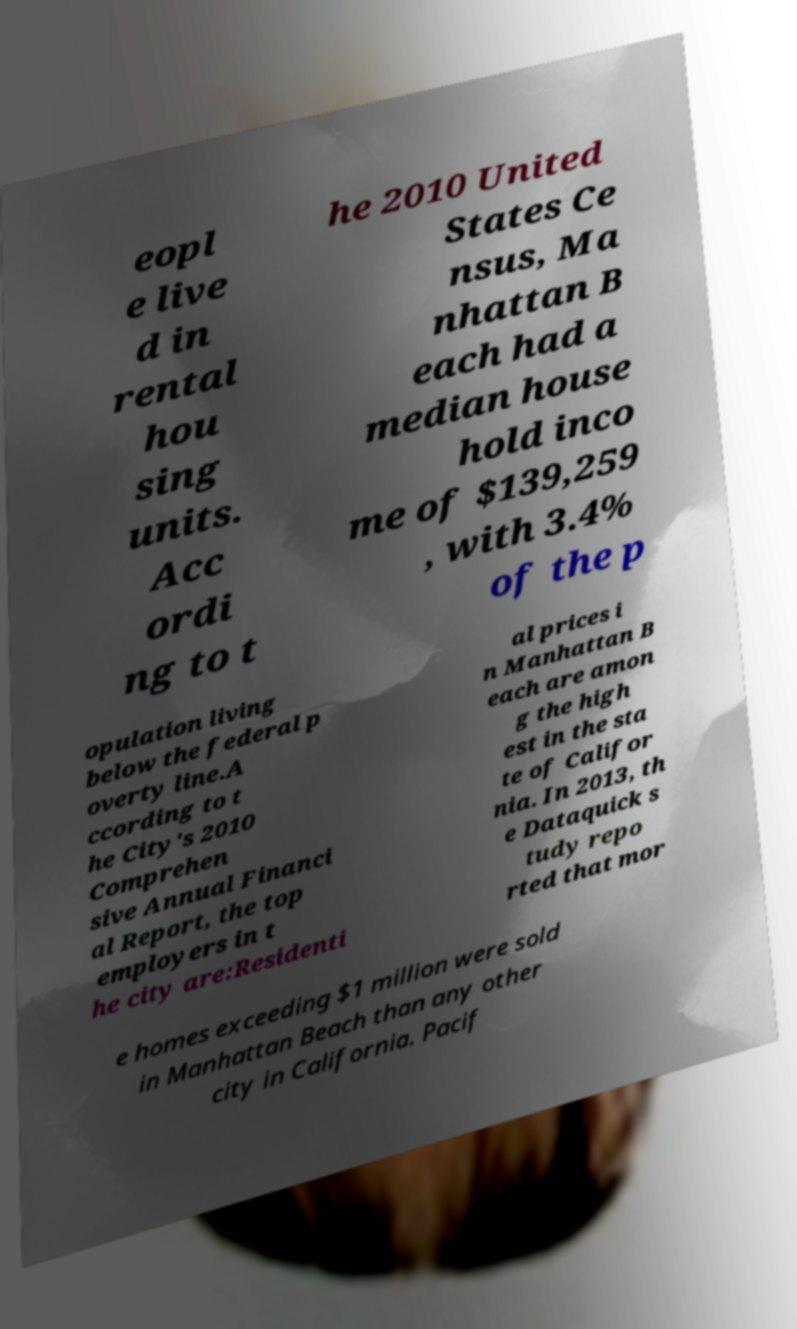Can you accurately transcribe the text from the provided image for me? eopl e live d in rental hou sing units. Acc ordi ng to t he 2010 United States Ce nsus, Ma nhattan B each had a median house hold inco me of $139,259 , with 3.4% of the p opulation living below the federal p overty line.A ccording to t he City's 2010 Comprehen sive Annual Financi al Report, the top employers in t he city are:Residenti al prices i n Manhattan B each are amon g the high est in the sta te of Califor nia. In 2013, th e Dataquick s tudy repo rted that mor e homes exceeding $1 million were sold in Manhattan Beach than any other city in California. Pacif 